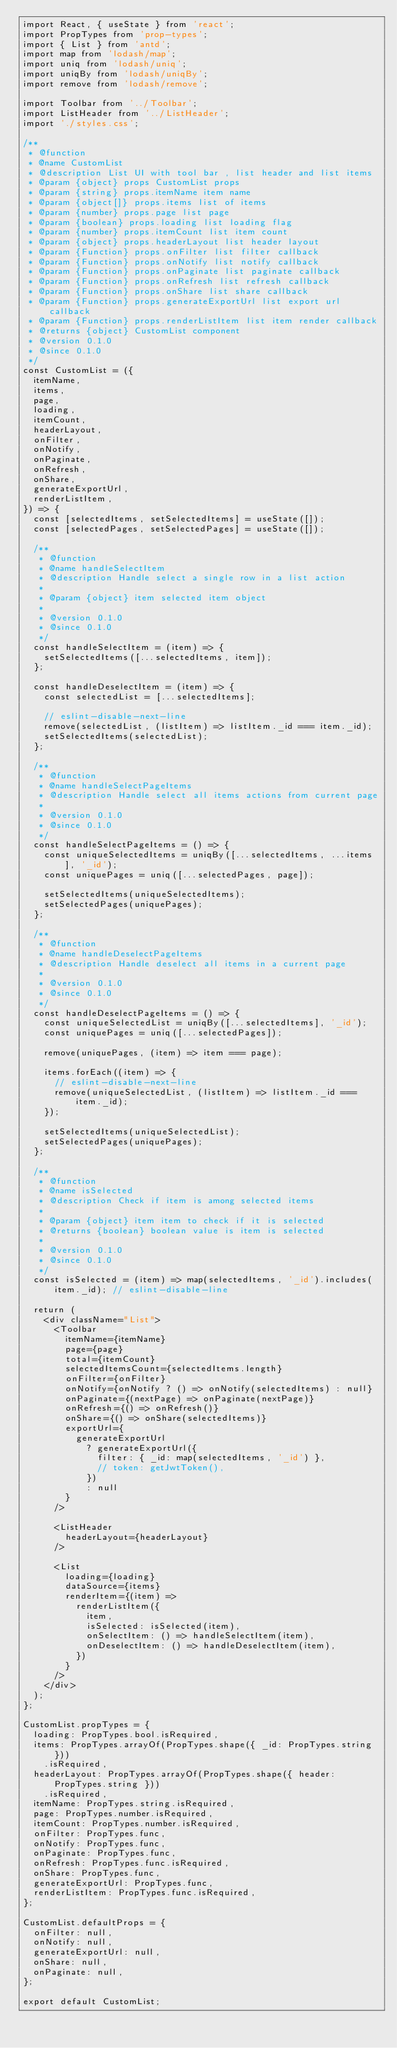<code> <loc_0><loc_0><loc_500><loc_500><_JavaScript_>import React, { useState } from 'react';
import PropTypes from 'prop-types';
import { List } from 'antd';
import map from 'lodash/map';
import uniq from 'lodash/uniq';
import uniqBy from 'lodash/uniqBy';
import remove from 'lodash/remove';

import Toolbar from '../Toolbar';
import ListHeader from '../ListHeader';
import './styles.css';

/**
 * @function
 * @name CustomList
 * @description List UI with tool bar , list header and list items
 * @param {object} props CustomList props
 * @param {string} props.itemName item name
 * @param {object[]} props.items list of items
 * @param {number} props.page list page
 * @param {boolean} props.loading list loading flag
 * @param {number} props.itemCount list item count
 * @param {object} props.headerLayout list header layout
 * @param {Function} props.onFilter list filter callback
 * @param {Function} props.onNotify list notify callback
 * @param {Function} props.onPaginate list paginate callback
 * @param {Function} props.onRefresh list refresh callback
 * @param {Function} props.onShare list share callback
 * @param {Function} props.generateExportUrl list export url callback
 * @param {Function} props.renderListItem list item render callback
 * @returns {object} CustomList component
 * @version 0.1.0
 * @since 0.1.0
 */
const CustomList = ({
  itemName,
  items,
  page,
  loading,
  itemCount,
  headerLayout,
  onFilter,
  onNotify,
  onPaginate,
  onRefresh,
  onShare,
  generateExportUrl,
  renderListItem,
}) => {
  const [selectedItems, setSelectedItems] = useState([]);
  const [selectedPages, setSelectedPages] = useState([]);

  /**
   * @function
   * @name handleSelectItem
   * @description Handle select a single row in a list action
   *
   * @param {object} item selected item object
   *
   * @version 0.1.0
   * @since 0.1.0
   */
  const handleSelectItem = (item) => {
    setSelectedItems([...selectedItems, item]);
  };

  const handleDeselectItem = (item) => {
    const selectedList = [...selectedItems];

    // eslint-disable-next-line
    remove(selectedList, (listItem) => listItem._id === item._id);
    setSelectedItems(selectedList);
  };

  /**
   * @function
   * @name handleSelectPageItems
   * @description Handle select all items actions from current page
   *
   * @version 0.1.0
   * @since 0.1.0
   */
  const handleSelectPageItems = () => {
    const uniqueSelectedItems = uniqBy([...selectedItems, ...items], '_id');
    const uniquePages = uniq([...selectedPages, page]);

    setSelectedItems(uniqueSelectedItems);
    setSelectedPages(uniquePages);
  };

  /**
   * @function
   * @name handleDeselectPageItems
   * @description Handle deselect all items in a current page
   *
   * @version 0.1.0
   * @since 0.1.0
   */
  const handleDeselectPageItems = () => {
    const uniqueSelectedList = uniqBy([...selectedItems], '_id');
    const uniquePages = uniq([...selectedPages]);

    remove(uniquePages, (item) => item === page);

    items.forEach((item) => {
      // eslint-disable-next-line
      remove(uniqueSelectedList, (listItem) => listItem._id === item._id);
    });

    setSelectedItems(uniqueSelectedList);
    setSelectedPages(uniquePages);
  };

  /**
   * @function
   * @name isSelected
   * @description Check if item is among selected items
   *
   * @param {object} item item to check if it is selected
   * @returns {boolean} boolean value is item is selected
   *
   * @version 0.1.0
   * @since 0.1.0
   */
  const isSelected = (item) => map(selectedItems, '_id').includes(item._id); // eslint-disable-line

  return (
    <div className="List">
      <Toolbar
        itemName={itemName}
        page={page}
        total={itemCount}
        selectedItemsCount={selectedItems.length}
        onFilter={onFilter}
        onNotify={onNotify ? () => onNotify(selectedItems) : null}
        onPaginate={(nextPage) => onPaginate(nextPage)}
        onRefresh={() => onRefresh()}
        onShare={() => onShare(selectedItems)}
        exportUrl={
          generateExportUrl
            ? generateExportUrl({
              filter: { _id: map(selectedItems, '_id') },
              // token: getJwtToken(),
            })
            : null
        }
      />

      <ListHeader
        headerLayout={headerLayout}
      />

      <List
        loading={loading}
        dataSource={items}
        renderItem={(item) =>
          renderListItem({
            item,
            isSelected: isSelected(item),
            onSelectItem: () => handleSelectItem(item),
            onDeselectItem: () => handleDeselectItem(item),
          })
        }
      />
    </div>
  );
};

CustomList.propTypes = {
  loading: PropTypes.bool.isRequired,
  items: PropTypes.arrayOf(PropTypes.shape({ _id: PropTypes.string }))
    .isRequired,
  headerLayout: PropTypes.arrayOf(PropTypes.shape({ header: PropTypes.string }))
    .isRequired,
  itemName: PropTypes.string.isRequired,
  page: PropTypes.number.isRequired,
  itemCount: PropTypes.number.isRequired,
  onFilter: PropTypes.func,
  onNotify: PropTypes.func,
  onPaginate: PropTypes.func,
  onRefresh: PropTypes.func.isRequired,
  onShare: PropTypes.func,
  generateExportUrl: PropTypes.func,
  renderListItem: PropTypes.func.isRequired,
};

CustomList.defaultProps = {
  onFilter: null,
  onNotify: null,
  generateExportUrl: null,
  onShare: null,
  onPaginate: null,
};

export default CustomList;
</code> 